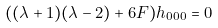<formula> <loc_0><loc_0><loc_500><loc_500>( ( \lambda + 1 ) ( \lambda - 2 ) + 6 F ) h _ { 0 0 0 } = 0</formula> 